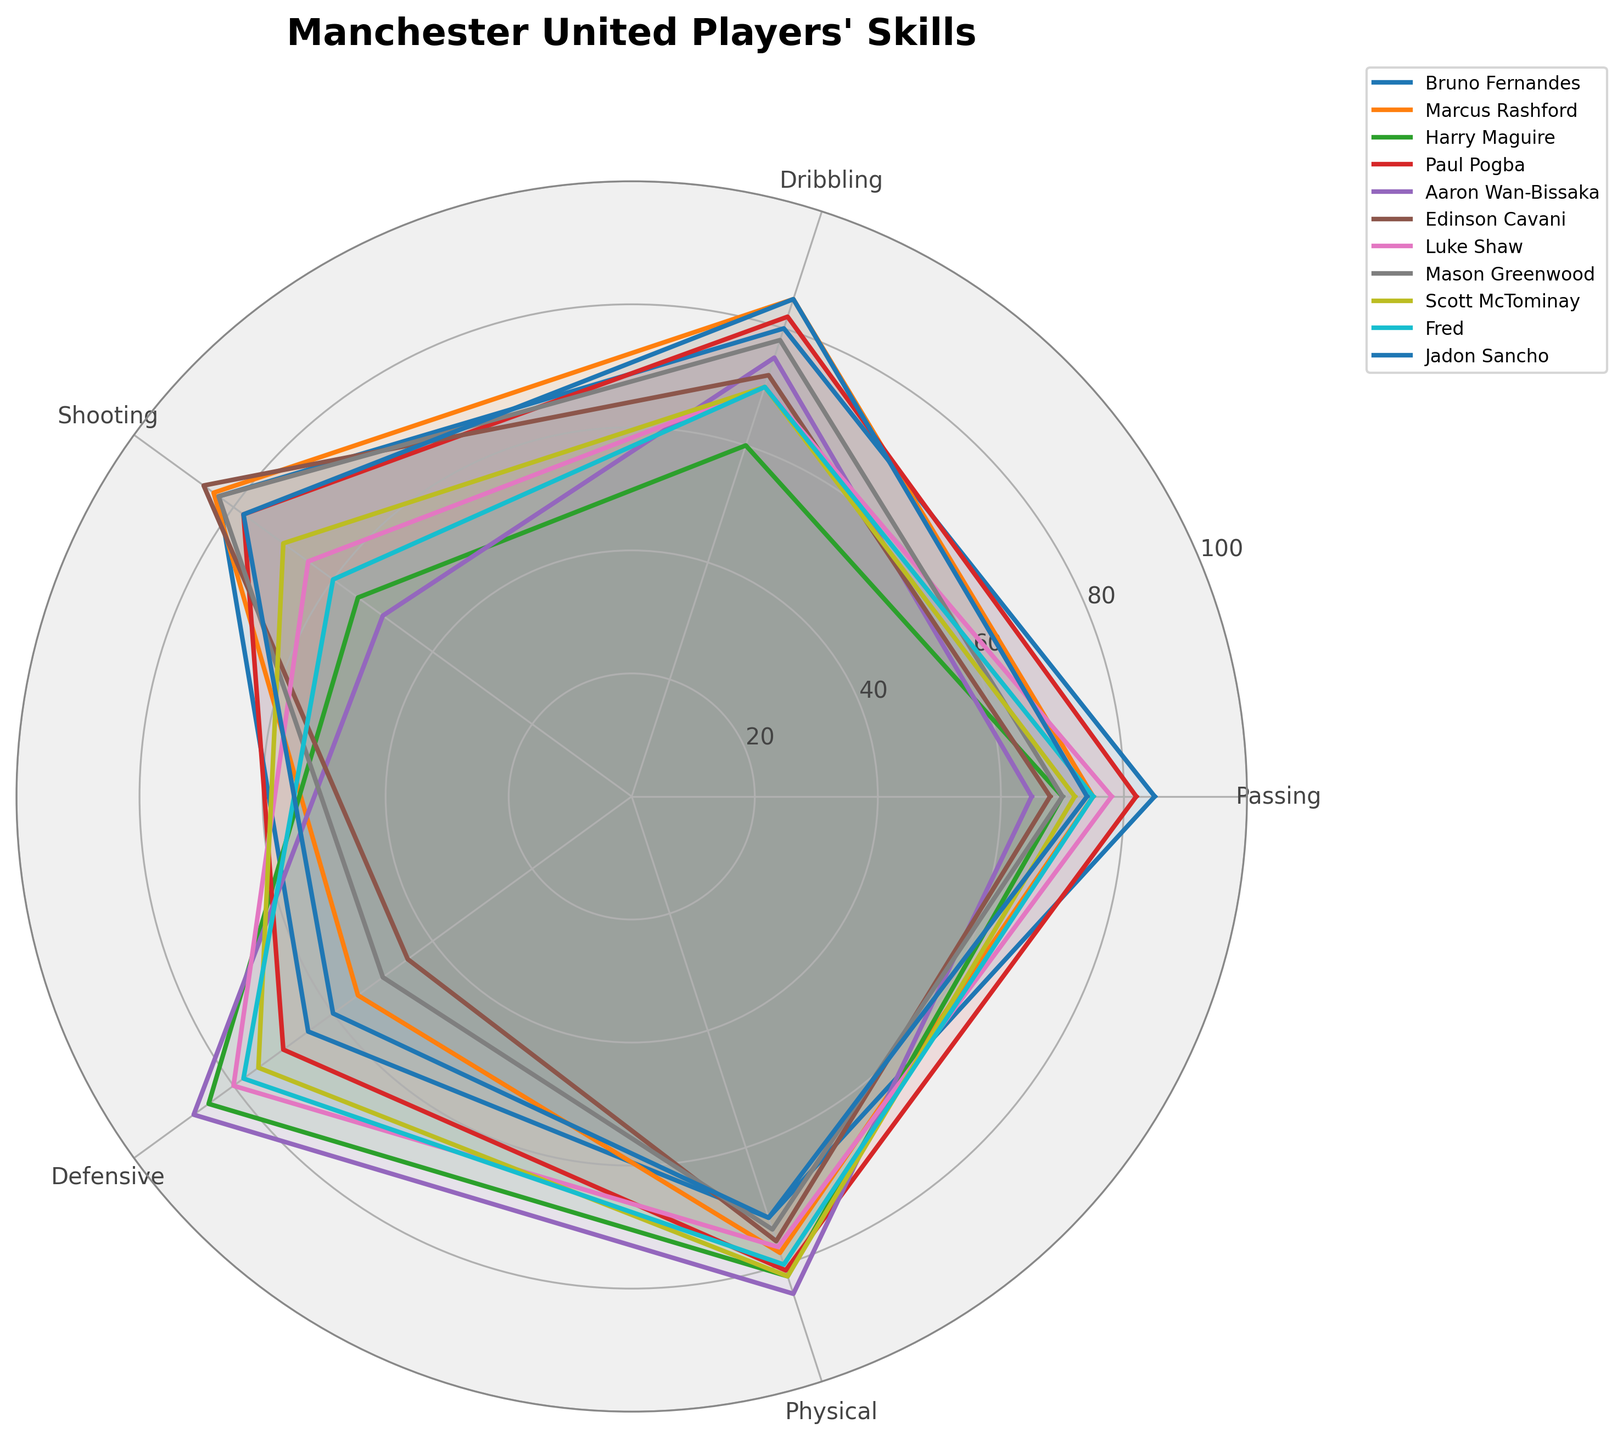What are the skill categories for Manchester United players shown in the radar chart? The radar chart includes the skill categories Passing, Dribbling, Shooting, Defensive, and Physical. These are the aspects of performance being measured for each player.
Answer: Passing, Dribbling, Shooting, Defensive, Physical Which player has the highest value in the Defensive category? By looking at the Defensive values represented on the radar chart, we see that Aaron Wan-Bissaka has the highest value in this category.
Answer: Aaron Wan-Bissaka Who is better at Dribbling, Marcus Rashford or Jadon Sancho? To determine who is better at Dribbling, compare the Dribbling values of Marcus Rashford and Jadon Sancho as shown on the radar chart. Both players have a Dribbling value of 85, which makes them equally proficient in this skill.
Answer: Both are equal Which player has the most balanced skill set across all categories? A balanced skill set means the player's performance is fairly equal across all categories. Looking at the radar chart, Paul Pogba has a relatively balanced distribution with no extreme highs or lows.
Answer: Paul Pogba What is the average Passing value of all the players? To calculate the average Passing value, sum up the Passing values for all the players and then divide by the number of players. Sum is (85 + 75 + 70 + 82 + 65 + 68 + 78 + 70 + 72 + 75 + 74) = 814. Divide by 11 players: 814/11 = 74.
Answer: 74 Which two players have the closest values in the Shooting category? By observing the Shooting values on the radar chart, Edinson Cavani (86) and Marcus Rashford (84) have the closest Shooting values.
Answer: Edinson Cavani and Marcus Rashford Does any player have a Physical value over 85? By inspecting the Physical values on the radar chart, Aaron Wan-Bissaka has a Physical value of 85, but no player has a value over 85.
Answer: No Who has the weakest Shooting skill among all the players? Looking at the lowest Shooting values on the radar chart, Aaron Wan-Bissaka has the weakest Shooting skill with a value of 50.
Answer: Aaron Wan-Bissaka How many players have a Defensive value of 75 or higher? Count the number of players with a Defensive value of 75 or higher on the radar chart. Players are Harry Maguire (85), Paul Pogba (70), Aaron Wan-Bissaka (88), Luke Shaw (80), Scott McTominay (75), and Fred (78). This gives us 6 players.
Answer: 6 Based on the plotted data, who would be considered more physically robust, Harry Maguire or Scott McTominay? Comparing the Physical values on the radar chart, Harry Maguire (82) and Scott McTominay (82) both have equal Physical scores, meaning they are equally physically robust.
Answer: Both are equal 